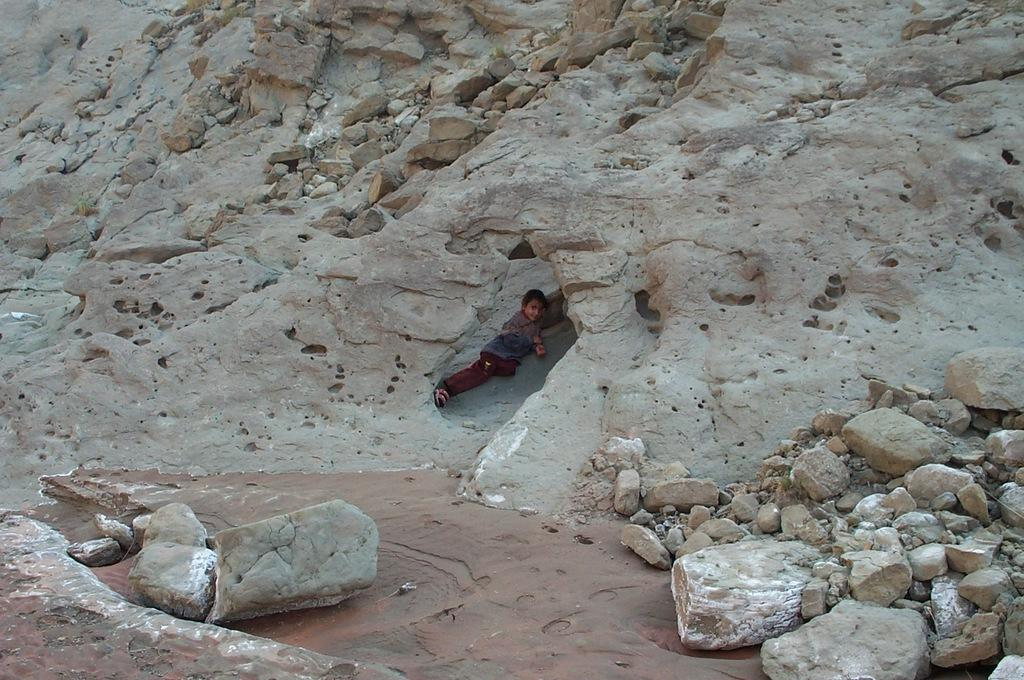What type of natural formation can be seen in the image? There are rocks in the image. Can you describe the person in the image? There is a person in the middle of the image. What type of kitty can be seen painting on the canvas in the image? There is no kitty or canvas present in the image; it features rocks and a person. What type of paper is the person holding in the image? There is no paper visible in the image; it only shows rocks and a person. 